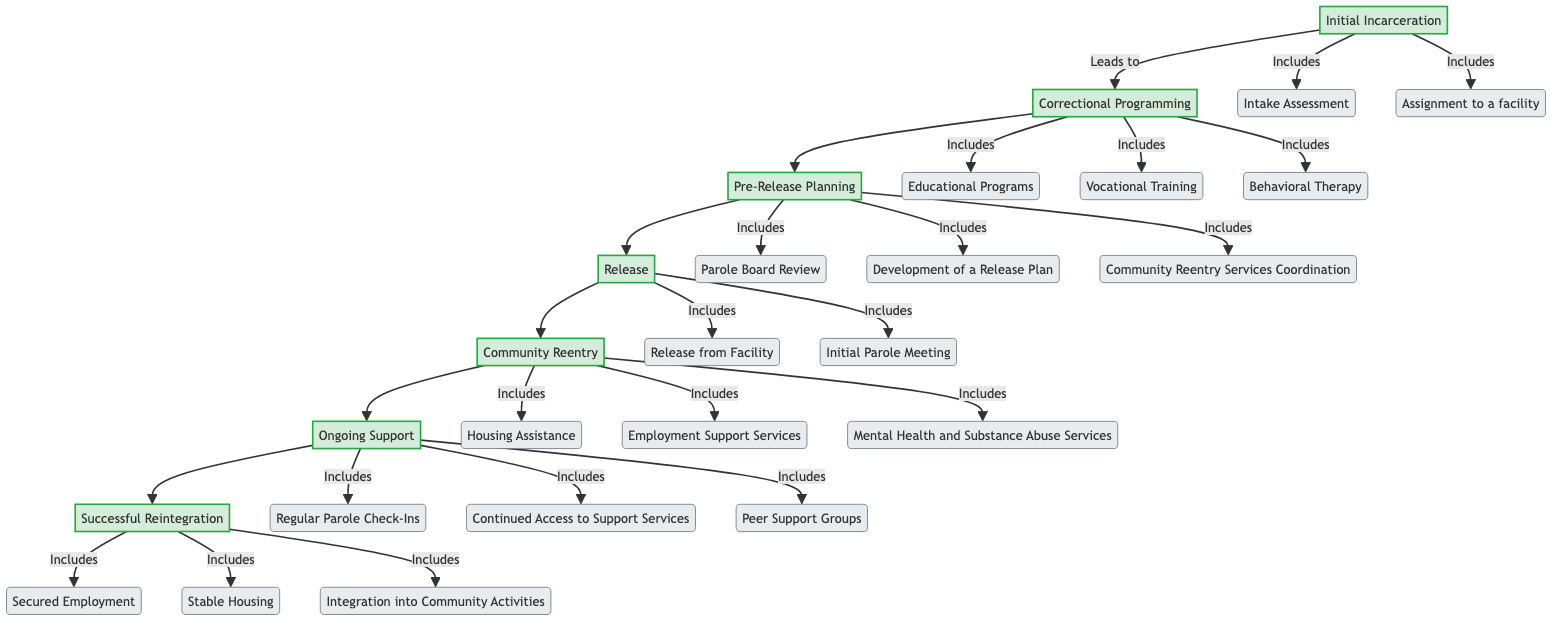What is the first step in the rehabilitation process? The diagram begins with "Initial Incarceration," which is the first step before any subsequent processes take place.
Answer: Initial Incarceration How many sub-steps are included in "Correctional Programming"? The "Correctional Programming" step includes three sub-steps: Educational Programs, Vocational Training, and Behavioral Therapy, making a total of three.
Answer: 3 What leads to "Pre-Release Planning"? The flowchart shows that "Correctional Programming" leads to "Pre-Release Planning," indicating that successful participation in correctional programs prepares individuals for release.
Answer: Correctional Programming What type of support services does "Community Reentry" provide? According to the diagram, "Community Reentry" includes services like Housing Assistance, Employment Support Services, and Mental Health and Substance Abuse Services, emphasizing the various types of support offered.
Answer: Housing Assistance, Employment Support Services, Mental Health and Substance Abuse Services Which step comes after "Release"? The diagram demonstrates that after "Release," the next step in the pathway is "Community Reentry," highlighting the transition from incarceration to community support.
Answer: Community Reentry What are the three components of "Successful Reintegration"? The diagram states that the components of "Successful Reintegration" include Secured Employment, Stable Housing, and Integration into Community Activities, which are crucial for achieving stability.
Answer: Secured Employment, Stable Housing, Integration into Community Activities What is the last step in the rehabilitation process? The final step highlighted in the flowchart is "Successful Reintegration," indicating that this is the ultimate goal of the entire process outlined in the diagram.
Answer: Successful Reintegration How many total steps are outlined in the diagram? The diagram lists a total of seven distinct steps from "Initial Incarceration" to "Successful Reintegration," showing the entire pathway of rehabilitation.
Answer: 7 What types of check-ins are included in "Ongoing Support"? "Ongoing Support" features Regular Parole Check-Ins, Continued Access to Support Services, and Peer Support Groups, which are essential for maintaining support during reintegration.
Answer: Regular Parole Check-Ins, Continued Access to Support Services, Peer Support Groups 